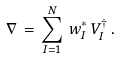Convert formula to latex. <formula><loc_0><loc_0><loc_500><loc_500>\nabla \, = \, \sum _ { I = 1 } ^ { N } \, w _ { I } ^ { * } \, V _ { I } ^ { \dagger } \, .</formula> 